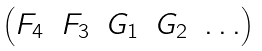<formula> <loc_0><loc_0><loc_500><loc_500>\begin{pmatrix} F _ { 4 } & F _ { 3 } & G _ { 1 } & G _ { 2 } & \dots \end{pmatrix}</formula> 